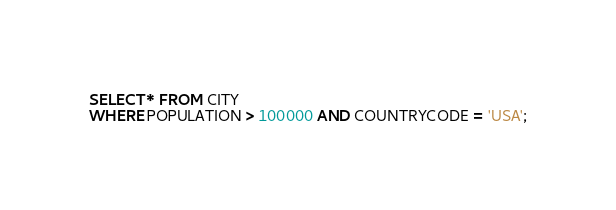<code> <loc_0><loc_0><loc_500><loc_500><_SQL_>SELECT * FROM CITY
WHERE POPULATION > 100000 AND COUNTRYCODE = 'USA';</code> 